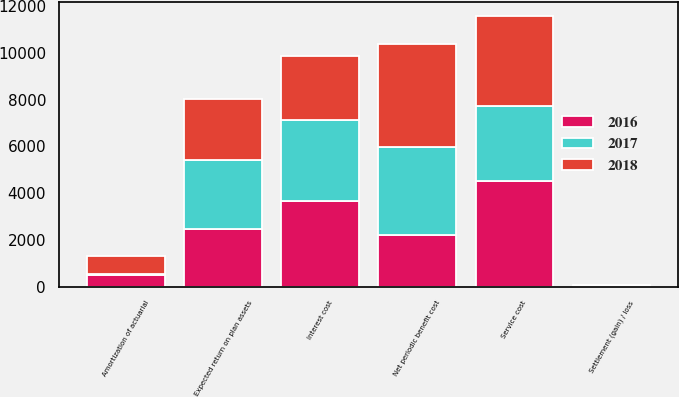<chart> <loc_0><loc_0><loc_500><loc_500><stacked_bar_chart><ecel><fcel>Service cost<fcel>Interest cost<fcel>Expected return on plan assets<fcel>Amortization of actuarial<fcel>Settlement (gain) / loss<fcel>Net periodic benefit cost<nl><fcel>2017<fcel>3215<fcel>3476<fcel>2949<fcel>54<fcel>74<fcel>3762<nl><fcel>2016<fcel>4525<fcel>3670<fcel>2467<fcel>473<fcel>4<fcel>2205<nl><fcel>2018<fcel>3843<fcel>2719<fcel>2624<fcel>762<fcel>2<fcel>4436<nl></chart> 